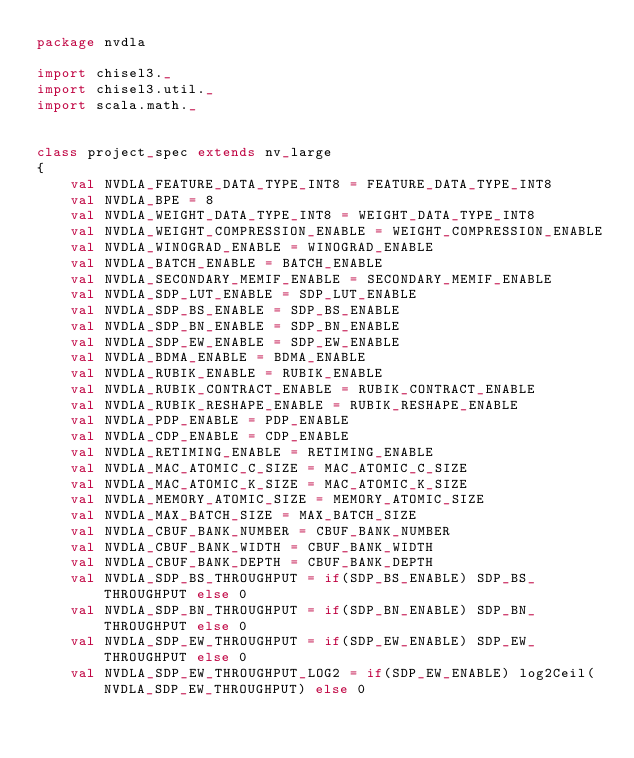<code> <loc_0><loc_0><loc_500><loc_500><_Scala_>package nvdla

import chisel3._
import chisel3.util._
import scala.math._


class project_spec extends nv_large
{
    val NVDLA_FEATURE_DATA_TYPE_INT8 = FEATURE_DATA_TYPE_INT8
    val NVDLA_BPE = 8
    val NVDLA_WEIGHT_DATA_TYPE_INT8 = WEIGHT_DATA_TYPE_INT8
    val NVDLA_WEIGHT_COMPRESSION_ENABLE = WEIGHT_COMPRESSION_ENABLE
    val NVDLA_WINOGRAD_ENABLE = WINOGRAD_ENABLE
    val NVDLA_BATCH_ENABLE = BATCH_ENABLE
    val NVDLA_SECONDARY_MEMIF_ENABLE = SECONDARY_MEMIF_ENABLE
    val NVDLA_SDP_LUT_ENABLE = SDP_LUT_ENABLE
    val NVDLA_SDP_BS_ENABLE = SDP_BS_ENABLE
    val NVDLA_SDP_BN_ENABLE = SDP_BN_ENABLE
    val NVDLA_SDP_EW_ENABLE = SDP_EW_ENABLE
    val NVDLA_BDMA_ENABLE = BDMA_ENABLE
    val NVDLA_RUBIK_ENABLE = RUBIK_ENABLE
    val NVDLA_RUBIK_CONTRACT_ENABLE = RUBIK_CONTRACT_ENABLE
    val NVDLA_RUBIK_RESHAPE_ENABLE = RUBIK_RESHAPE_ENABLE
    val NVDLA_PDP_ENABLE = PDP_ENABLE
    val NVDLA_CDP_ENABLE = CDP_ENABLE
    val NVDLA_RETIMING_ENABLE = RETIMING_ENABLE
    val NVDLA_MAC_ATOMIC_C_SIZE = MAC_ATOMIC_C_SIZE
    val NVDLA_MAC_ATOMIC_K_SIZE = MAC_ATOMIC_K_SIZE
    val NVDLA_MEMORY_ATOMIC_SIZE = MEMORY_ATOMIC_SIZE
    val NVDLA_MAX_BATCH_SIZE = MAX_BATCH_SIZE
    val NVDLA_CBUF_BANK_NUMBER = CBUF_BANK_NUMBER
    val NVDLA_CBUF_BANK_WIDTH = CBUF_BANK_WIDTH
    val NVDLA_CBUF_BANK_DEPTH = CBUF_BANK_DEPTH
    val NVDLA_SDP_BS_THROUGHPUT = if(SDP_BS_ENABLE) SDP_BS_THROUGHPUT else 0
    val NVDLA_SDP_BN_THROUGHPUT = if(SDP_BN_ENABLE) SDP_BN_THROUGHPUT else 0
    val NVDLA_SDP_EW_THROUGHPUT = if(SDP_EW_ENABLE) SDP_EW_THROUGHPUT else 0 
    val NVDLA_SDP_EW_THROUGHPUT_LOG2 = if(SDP_EW_ENABLE) log2Ceil(NVDLA_SDP_EW_THROUGHPUT) else 0</code> 